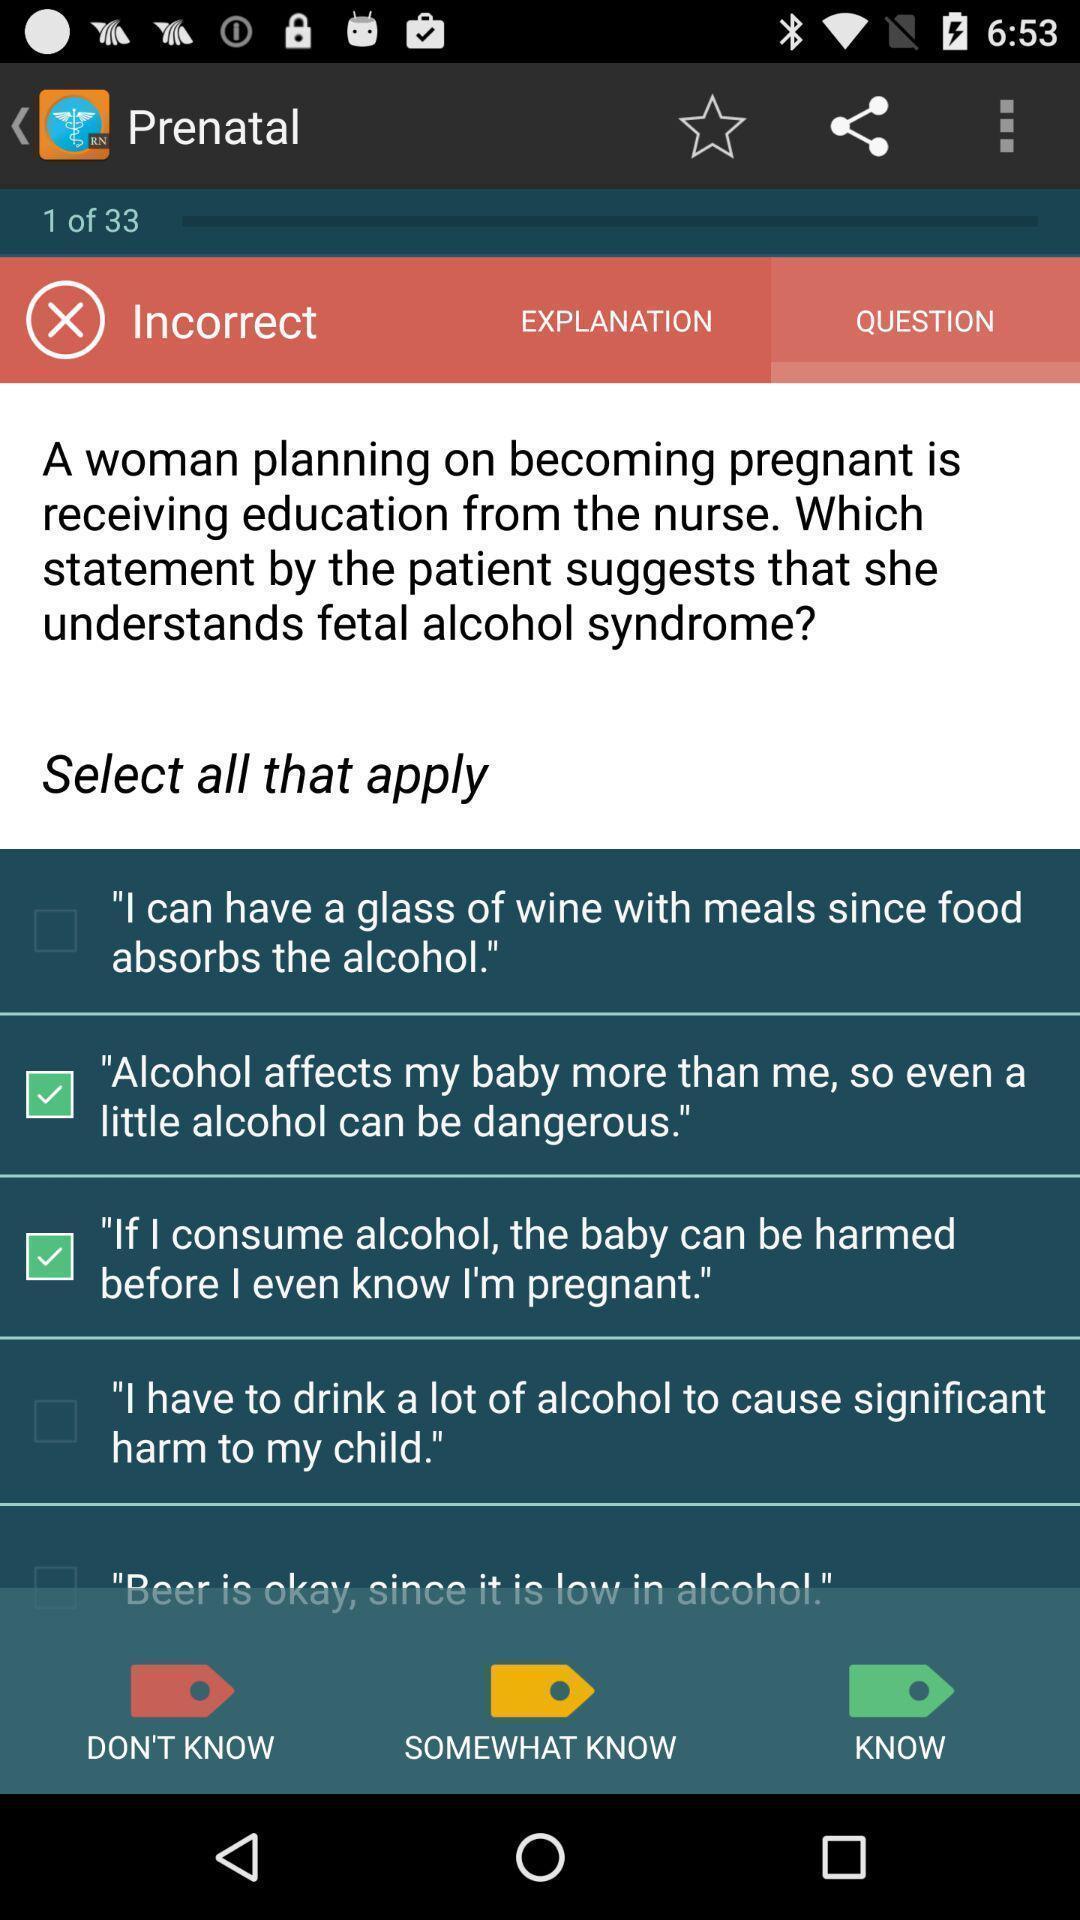Provide a detailed account of this screenshot. Page displaying the health precautions for pregnant woman. 